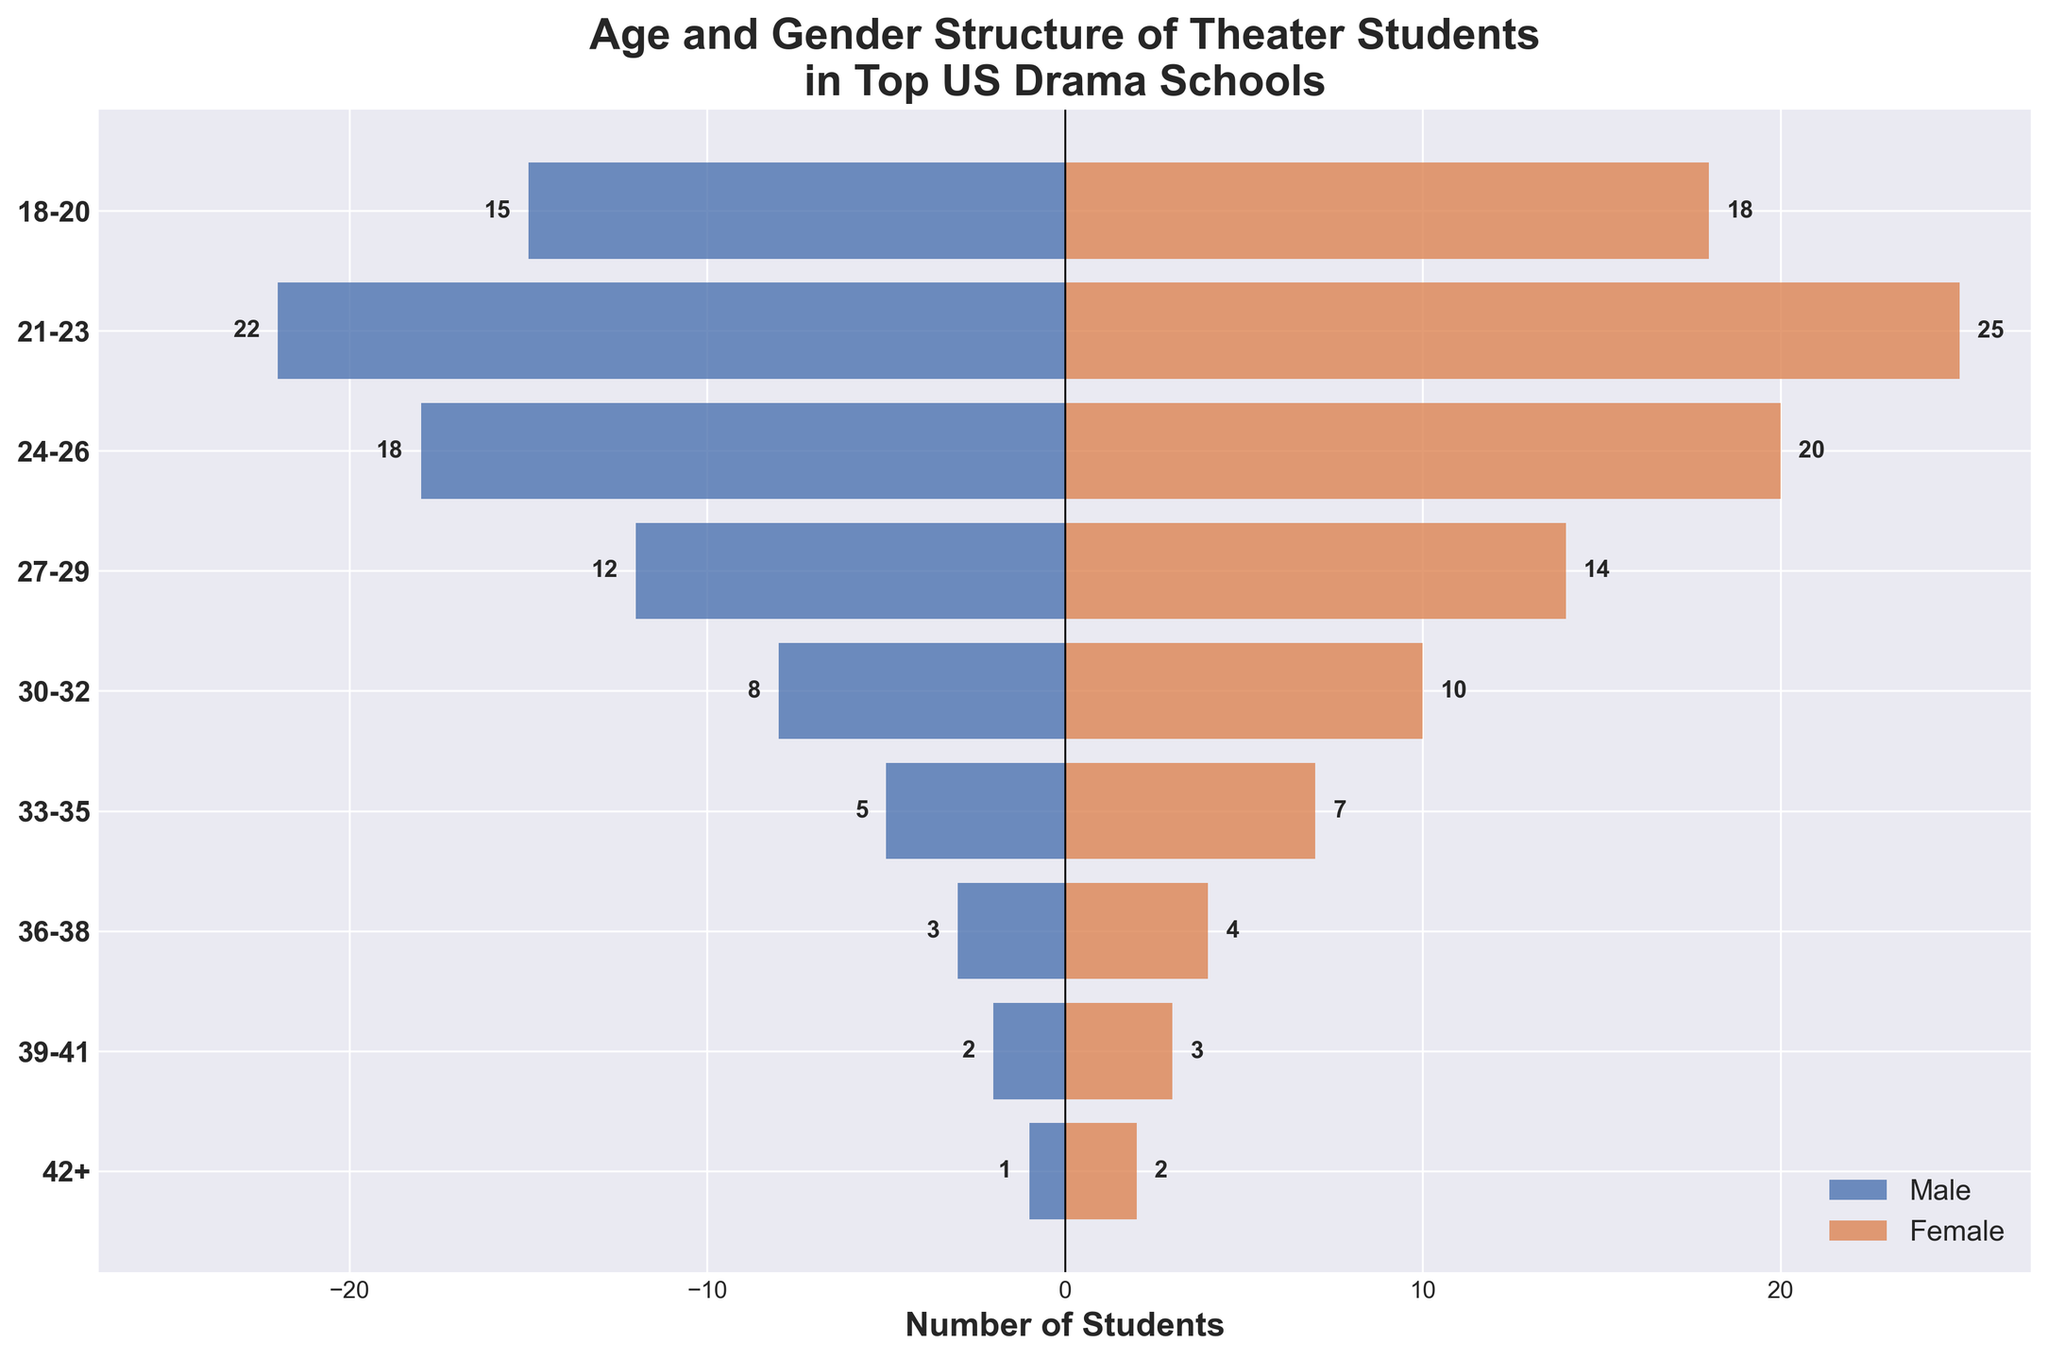What's the title of the figure? The title of the figure is usually found at the top and it's meant to deliver the main message of the visual.
Answer: Age and Gender Structure of Theater Students in Top US Drama Schools How many age groups are represented in the figure? Count the distinct categories listed on the y-axis.
Answer: 9 Which age group has the highest number of male theater students? Look at the horizontal bars representing males and identify the longest one.
Answer: 21-23 What's the total number of students (both genders) in the 18-20 age group? Add up the number of male and female students in the 18-20 group: 15 males + 18 females.
Answer: 33 How many more female students are there compared to male students in the 21-23 age group? Subtract the number of male students from the number of female students in the 21-23 age group: 25 females - 22 males.
Answer: 3 In which age group is the gender distribution most balanced? Look for the age group where the difference in the number of male and female students is the smallest.
Answer: 42+ Which gender has a higher total number of students across all age groups? Sum the number of male and female students separately and compare the totals: 
   - Male: 15+22+18+12+8+5+3+2+1 = 86
   - Female: 18+25+20+14+10+7+4+3+2 = 103.
Answer: Female What is the trend in the number of theater students as the age increases? Observe the length of the bars as the age groups progress from youngest to oldest.
Answer: Decreases Are there more students in the 24-26 or the 27-29 age group? Compare the sum of male and female students in both age groups: 
   - 24-26: 18 (males) + 20 (females) = 38
   - 27-29: 12 (males) + 14 (females) = 26.
Answer: 24-26 